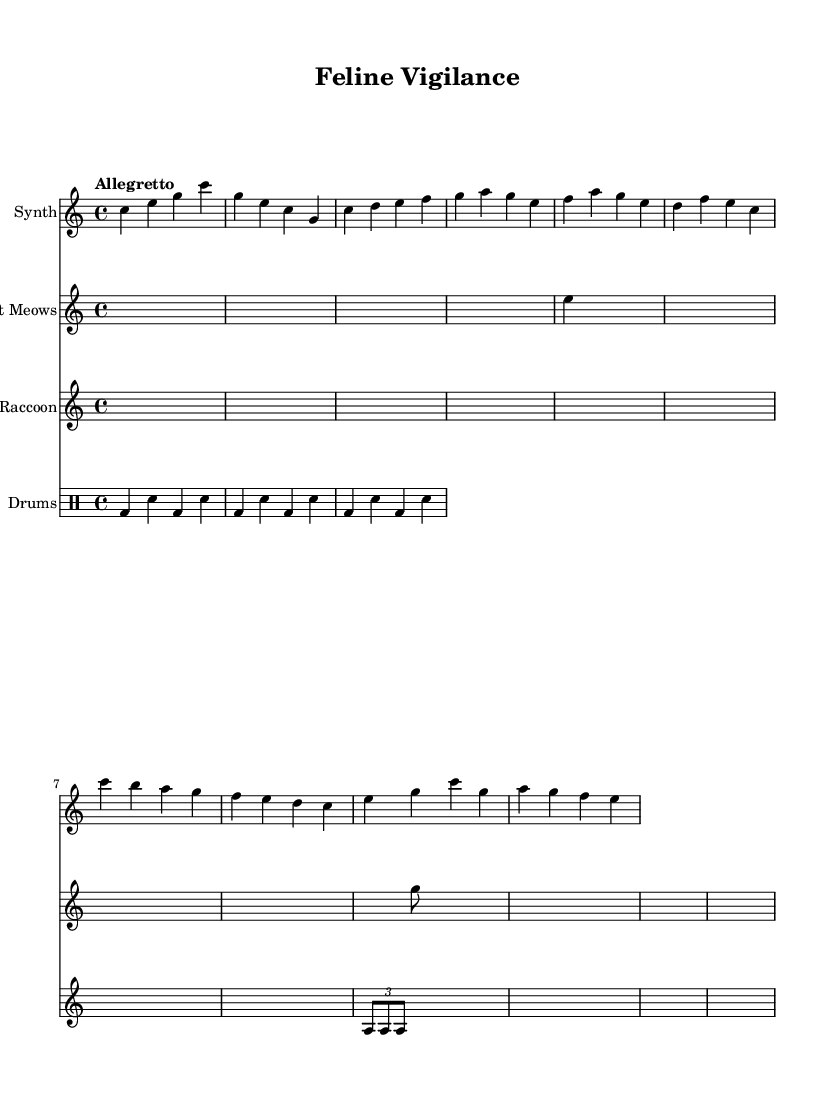What is the key signature of this music? The key signature is indicated at the beginning of the staff, showing no sharps or flats, which corresponds to C major.
Answer: C major What is the time signature of this music? The time signature is displayed at the beginning of the score, showing that there are four beats in each measure, which is represented as 4/4.
Answer: 4/4 What is the tempo marking for this piece? The tempo marking is found at the top of the score indicating the pace at which the piece should be played. It states "Allegretto," which is a moderate tempo.
Answer: Allegretto How many measures are in the synthesizer section? By counting the measures in the synthesizer staff, there are a total of 8 measures, as indicated by the grouped notes separated by vertical lines.
Answer: 8 What kind of sampled sounds are featured in this track? The track includes sampled sounds particularly from cats, represented in the staff labeled "Cat Meows," and from raccoons, shown in the staff labeled "Raccoon."
Answer: Cat meows and raccoon chatter What rhythmic pattern is used in the drum section? The drum pattern section uses a repeating sequence of bass drum and snare hits, specifically detailed as "bd" for bass drum and "sn" for snare across three measures, repeated.
Answer: Bass drum and snare pattern What type of musical instrument is indicated by the staff labeled "Synth"? The staff labeled "Synth" indicates that a synthesizer instrument is being used, as denoted by the instrument name beneath the staff.
Answer: Synthesizer 